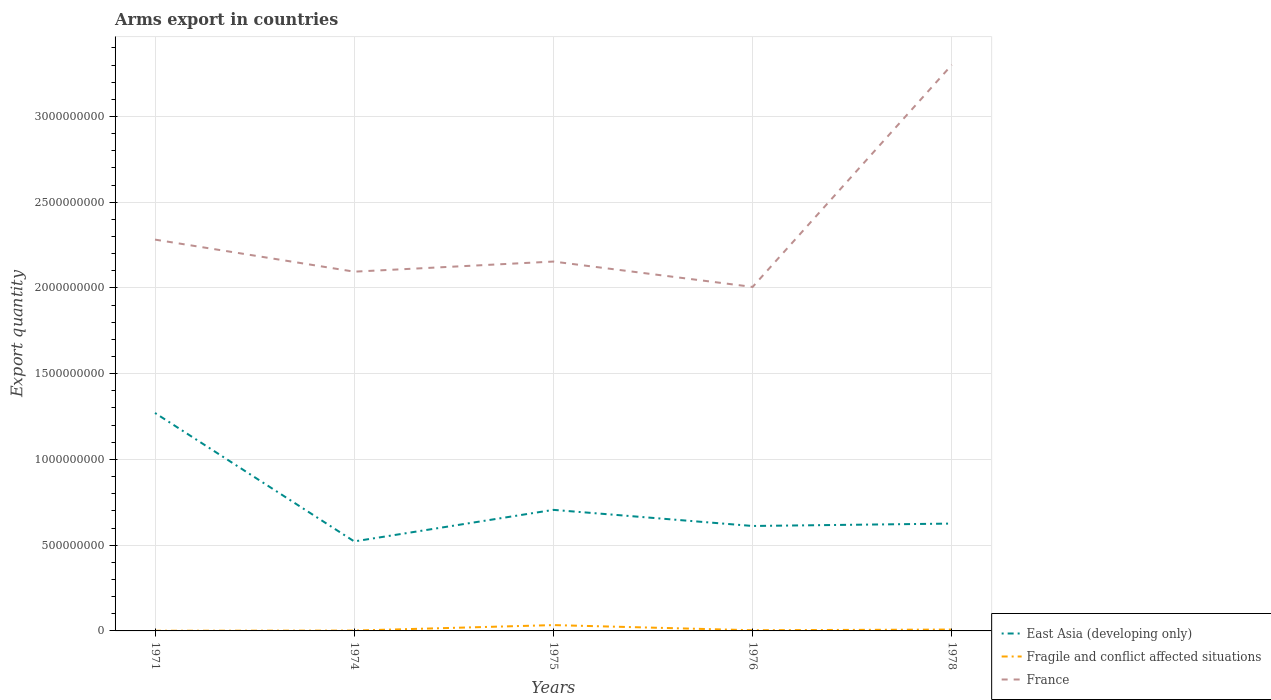How many different coloured lines are there?
Ensure brevity in your answer.  3. Across all years, what is the maximum total arms export in Fragile and conflict affected situations?
Keep it short and to the point. 1.00e+06. What is the total total arms export in East Asia (developing only) in the graph?
Provide a short and direct response. 5.65e+08. What is the difference between the highest and the second highest total arms export in Fragile and conflict affected situations?
Provide a succinct answer. 3.30e+07. Is the total arms export in Fragile and conflict affected situations strictly greater than the total arms export in France over the years?
Offer a terse response. Yes. Are the values on the major ticks of Y-axis written in scientific E-notation?
Make the answer very short. No. Does the graph contain any zero values?
Give a very brief answer. No. Does the graph contain grids?
Your answer should be very brief. Yes. Where does the legend appear in the graph?
Your answer should be compact. Bottom right. What is the title of the graph?
Your response must be concise. Arms export in countries. What is the label or title of the X-axis?
Provide a short and direct response. Years. What is the label or title of the Y-axis?
Make the answer very short. Export quantity. What is the Export quantity in East Asia (developing only) in 1971?
Your answer should be compact. 1.27e+09. What is the Export quantity of France in 1971?
Offer a very short reply. 2.28e+09. What is the Export quantity of East Asia (developing only) in 1974?
Keep it short and to the point. 5.22e+08. What is the Export quantity in France in 1974?
Provide a succinct answer. 2.10e+09. What is the Export quantity in East Asia (developing only) in 1975?
Make the answer very short. 7.06e+08. What is the Export quantity in Fragile and conflict affected situations in 1975?
Your answer should be compact. 3.40e+07. What is the Export quantity of France in 1975?
Your answer should be very brief. 2.15e+09. What is the Export quantity in East Asia (developing only) in 1976?
Provide a short and direct response. 6.12e+08. What is the Export quantity in France in 1976?
Provide a short and direct response. 2.01e+09. What is the Export quantity of East Asia (developing only) in 1978?
Make the answer very short. 6.26e+08. What is the Export quantity in France in 1978?
Keep it short and to the point. 3.30e+09. Across all years, what is the maximum Export quantity of East Asia (developing only)?
Provide a short and direct response. 1.27e+09. Across all years, what is the maximum Export quantity of Fragile and conflict affected situations?
Keep it short and to the point. 3.40e+07. Across all years, what is the maximum Export quantity of France?
Offer a terse response. 3.30e+09. Across all years, what is the minimum Export quantity of East Asia (developing only)?
Give a very brief answer. 5.22e+08. Across all years, what is the minimum Export quantity of Fragile and conflict affected situations?
Ensure brevity in your answer.  1.00e+06. Across all years, what is the minimum Export quantity of France?
Your answer should be compact. 2.01e+09. What is the total Export quantity in East Asia (developing only) in the graph?
Keep it short and to the point. 3.74e+09. What is the total Export quantity in Fragile and conflict affected situations in the graph?
Give a very brief answer. 4.90e+07. What is the total Export quantity of France in the graph?
Provide a succinct answer. 1.18e+1. What is the difference between the Export quantity of East Asia (developing only) in 1971 and that in 1974?
Offer a very short reply. 7.49e+08. What is the difference between the Export quantity in Fragile and conflict affected situations in 1971 and that in 1974?
Offer a very short reply. -1.00e+06. What is the difference between the Export quantity of France in 1971 and that in 1974?
Keep it short and to the point. 1.87e+08. What is the difference between the Export quantity of East Asia (developing only) in 1971 and that in 1975?
Ensure brevity in your answer.  5.65e+08. What is the difference between the Export quantity of Fragile and conflict affected situations in 1971 and that in 1975?
Offer a terse response. -3.30e+07. What is the difference between the Export quantity of France in 1971 and that in 1975?
Your answer should be very brief. 1.28e+08. What is the difference between the Export quantity in East Asia (developing only) in 1971 and that in 1976?
Your response must be concise. 6.59e+08. What is the difference between the Export quantity in France in 1971 and that in 1976?
Your answer should be very brief. 2.76e+08. What is the difference between the Export quantity of East Asia (developing only) in 1971 and that in 1978?
Keep it short and to the point. 6.45e+08. What is the difference between the Export quantity of Fragile and conflict affected situations in 1971 and that in 1978?
Offer a very short reply. -7.00e+06. What is the difference between the Export quantity of France in 1971 and that in 1978?
Make the answer very short. -1.02e+09. What is the difference between the Export quantity of East Asia (developing only) in 1974 and that in 1975?
Ensure brevity in your answer.  -1.84e+08. What is the difference between the Export quantity in Fragile and conflict affected situations in 1974 and that in 1975?
Provide a succinct answer. -3.20e+07. What is the difference between the Export quantity in France in 1974 and that in 1975?
Make the answer very short. -5.90e+07. What is the difference between the Export quantity of East Asia (developing only) in 1974 and that in 1976?
Provide a succinct answer. -9.00e+07. What is the difference between the Export quantity in Fragile and conflict affected situations in 1974 and that in 1976?
Your answer should be very brief. -2.00e+06. What is the difference between the Export quantity in France in 1974 and that in 1976?
Make the answer very short. 8.90e+07. What is the difference between the Export quantity of East Asia (developing only) in 1974 and that in 1978?
Provide a succinct answer. -1.04e+08. What is the difference between the Export quantity in Fragile and conflict affected situations in 1974 and that in 1978?
Offer a terse response. -6.00e+06. What is the difference between the Export quantity in France in 1974 and that in 1978?
Provide a succinct answer. -1.21e+09. What is the difference between the Export quantity of East Asia (developing only) in 1975 and that in 1976?
Keep it short and to the point. 9.40e+07. What is the difference between the Export quantity of Fragile and conflict affected situations in 1975 and that in 1976?
Your answer should be very brief. 3.00e+07. What is the difference between the Export quantity in France in 1975 and that in 1976?
Ensure brevity in your answer.  1.48e+08. What is the difference between the Export quantity of East Asia (developing only) in 1975 and that in 1978?
Offer a terse response. 8.00e+07. What is the difference between the Export quantity in Fragile and conflict affected situations in 1975 and that in 1978?
Keep it short and to the point. 2.60e+07. What is the difference between the Export quantity of France in 1975 and that in 1978?
Your answer should be very brief. -1.15e+09. What is the difference between the Export quantity in East Asia (developing only) in 1976 and that in 1978?
Your answer should be very brief. -1.40e+07. What is the difference between the Export quantity in France in 1976 and that in 1978?
Your answer should be very brief. -1.30e+09. What is the difference between the Export quantity of East Asia (developing only) in 1971 and the Export quantity of Fragile and conflict affected situations in 1974?
Your response must be concise. 1.27e+09. What is the difference between the Export quantity in East Asia (developing only) in 1971 and the Export quantity in France in 1974?
Your answer should be very brief. -8.24e+08. What is the difference between the Export quantity in Fragile and conflict affected situations in 1971 and the Export quantity in France in 1974?
Ensure brevity in your answer.  -2.09e+09. What is the difference between the Export quantity of East Asia (developing only) in 1971 and the Export quantity of Fragile and conflict affected situations in 1975?
Your answer should be very brief. 1.24e+09. What is the difference between the Export quantity of East Asia (developing only) in 1971 and the Export quantity of France in 1975?
Your answer should be very brief. -8.83e+08. What is the difference between the Export quantity in Fragile and conflict affected situations in 1971 and the Export quantity in France in 1975?
Offer a very short reply. -2.15e+09. What is the difference between the Export quantity in East Asia (developing only) in 1971 and the Export quantity in Fragile and conflict affected situations in 1976?
Ensure brevity in your answer.  1.27e+09. What is the difference between the Export quantity of East Asia (developing only) in 1971 and the Export quantity of France in 1976?
Ensure brevity in your answer.  -7.35e+08. What is the difference between the Export quantity of Fragile and conflict affected situations in 1971 and the Export quantity of France in 1976?
Your answer should be compact. -2.00e+09. What is the difference between the Export quantity in East Asia (developing only) in 1971 and the Export quantity in Fragile and conflict affected situations in 1978?
Your answer should be compact. 1.26e+09. What is the difference between the Export quantity in East Asia (developing only) in 1971 and the Export quantity in France in 1978?
Provide a short and direct response. -2.03e+09. What is the difference between the Export quantity in Fragile and conflict affected situations in 1971 and the Export quantity in France in 1978?
Provide a succinct answer. -3.30e+09. What is the difference between the Export quantity in East Asia (developing only) in 1974 and the Export quantity in Fragile and conflict affected situations in 1975?
Make the answer very short. 4.88e+08. What is the difference between the Export quantity in East Asia (developing only) in 1974 and the Export quantity in France in 1975?
Ensure brevity in your answer.  -1.63e+09. What is the difference between the Export quantity in Fragile and conflict affected situations in 1974 and the Export quantity in France in 1975?
Provide a short and direct response. -2.15e+09. What is the difference between the Export quantity in East Asia (developing only) in 1974 and the Export quantity in Fragile and conflict affected situations in 1976?
Your answer should be very brief. 5.18e+08. What is the difference between the Export quantity of East Asia (developing only) in 1974 and the Export quantity of France in 1976?
Provide a short and direct response. -1.48e+09. What is the difference between the Export quantity in Fragile and conflict affected situations in 1974 and the Export quantity in France in 1976?
Your response must be concise. -2.00e+09. What is the difference between the Export quantity in East Asia (developing only) in 1974 and the Export quantity in Fragile and conflict affected situations in 1978?
Provide a succinct answer. 5.14e+08. What is the difference between the Export quantity of East Asia (developing only) in 1974 and the Export quantity of France in 1978?
Ensure brevity in your answer.  -2.78e+09. What is the difference between the Export quantity of Fragile and conflict affected situations in 1974 and the Export quantity of France in 1978?
Your response must be concise. -3.30e+09. What is the difference between the Export quantity in East Asia (developing only) in 1975 and the Export quantity in Fragile and conflict affected situations in 1976?
Provide a succinct answer. 7.02e+08. What is the difference between the Export quantity in East Asia (developing only) in 1975 and the Export quantity in France in 1976?
Your response must be concise. -1.30e+09. What is the difference between the Export quantity in Fragile and conflict affected situations in 1975 and the Export quantity in France in 1976?
Offer a terse response. -1.97e+09. What is the difference between the Export quantity of East Asia (developing only) in 1975 and the Export quantity of Fragile and conflict affected situations in 1978?
Give a very brief answer. 6.98e+08. What is the difference between the Export quantity of East Asia (developing only) in 1975 and the Export quantity of France in 1978?
Provide a short and direct response. -2.60e+09. What is the difference between the Export quantity of Fragile and conflict affected situations in 1975 and the Export quantity of France in 1978?
Offer a very short reply. -3.27e+09. What is the difference between the Export quantity of East Asia (developing only) in 1976 and the Export quantity of Fragile and conflict affected situations in 1978?
Make the answer very short. 6.04e+08. What is the difference between the Export quantity of East Asia (developing only) in 1976 and the Export quantity of France in 1978?
Your answer should be very brief. -2.69e+09. What is the difference between the Export quantity in Fragile and conflict affected situations in 1976 and the Export quantity in France in 1978?
Offer a terse response. -3.30e+09. What is the average Export quantity in East Asia (developing only) per year?
Provide a short and direct response. 7.47e+08. What is the average Export quantity in Fragile and conflict affected situations per year?
Provide a short and direct response. 9.80e+06. What is the average Export quantity in France per year?
Your response must be concise. 2.37e+09. In the year 1971, what is the difference between the Export quantity in East Asia (developing only) and Export quantity in Fragile and conflict affected situations?
Offer a very short reply. 1.27e+09. In the year 1971, what is the difference between the Export quantity of East Asia (developing only) and Export quantity of France?
Offer a very short reply. -1.01e+09. In the year 1971, what is the difference between the Export quantity of Fragile and conflict affected situations and Export quantity of France?
Provide a succinct answer. -2.28e+09. In the year 1974, what is the difference between the Export quantity in East Asia (developing only) and Export quantity in Fragile and conflict affected situations?
Give a very brief answer. 5.20e+08. In the year 1974, what is the difference between the Export quantity of East Asia (developing only) and Export quantity of France?
Offer a very short reply. -1.57e+09. In the year 1974, what is the difference between the Export quantity in Fragile and conflict affected situations and Export quantity in France?
Your answer should be very brief. -2.09e+09. In the year 1975, what is the difference between the Export quantity of East Asia (developing only) and Export quantity of Fragile and conflict affected situations?
Keep it short and to the point. 6.72e+08. In the year 1975, what is the difference between the Export quantity of East Asia (developing only) and Export quantity of France?
Provide a succinct answer. -1.45e+09. In the year 1975, what is the difference between the Export quantity in Fragile and conflict affected situations and Export quantity in France?
Your answer should be compact. -2.12e+09. In the year 1976, what is the difference between the Export quantity of East Asia (developing only) and Export quantity of Fragile and conflict affected situations?
Keep it short and to the point. 6.08e+08. In the year 1976, what is the difference between the Export quantity of East Asia (developing only) and Export quantity of France?
Provide a short and direct response. -1.39e+09. In the year 1976, what is the difference between the Export quantity in Fragile and conflict affected situations and Export quantity in France?
Offer a terse response. -2.00e+09. In the year 1978, what is the difference between the Export quantity in East Asia (developing only) and Export quantity in Fragile and conflict affected situations?
Your answer should be very brief. 6.18e+08. In the year 1978, what is the difference between the Export quantity of East Asia (developing only) and Export quantity of France?
Your answer should be compact. -2.68e+09. In the year 1978, what is the difference between the Export quantity in Fragile and conflict affected situations and Export quantity in France?
Give a very brief answer. -3.29e+09. What is the ratio of the Export quantity of East Asia (developing only) in 1971 to that in 1974?
Keep it short and to the point. 2.43. What is the ratio of the Export quantity of France in 1971 to that in 1974?
Ensure brevity in your answer.  1.09. What is the ratio of the Export quantity in East Asia (developing only) in 1971 to that in 1975?
Provide a short and direct response. 1.8. What is the ratio of the Export quantity in Fragile and conflict affected situations in 1971 to that in 1975?
Make the answer very short. 0.03. What is the ratio of the Export quantity of France in 1971 to that in 1975?
Keep it short and to the point. 1.06. What is the ratio of the Export quantity in East Asia (developing only) in 1971 to that in 1976?
Provide a short and direct response. 2.08. What is the ratio of the Export quantity of Fragile and conflict affected situations in 1971 to that in 1976?
Provide a succinct answer. 0.25. What is the ratio of the Export quantity of France in 1971 to that in 1976?
Offer a very short reply. 1.14. What is the ratio of the Export quantity in East Asia (developing only) in 1971 to that in 1978?
Offer a very short reply. 2.03. What is the ratio of the Export quantity in Fragile and conflict affected situations in 1971 to that in 1978?
Offer a very short reply. 0.12. What is the ratio of the Export quantity of France in 1971 to that in 1978?
Ensure brevity in your answer.  0.69. What is the ratio of the Export quantity of East Asia (developing only) in 1974 to that in 1975?
Ensure brevity in your answer.  0.74. What is the ratio of the Export quantity of Fragile and conflict affected situations in 1974 to that in 1975?
Your answer should be compact. 0.06. What is the ratio of the Export quantity of France in 1974 to that in 1975?
Offer a very short reply. 0.97. What is the ratio of the Export quantity of East Asia (developing only) in 1974 to that in 1976?
Your answer should be very brief. 0.85. What is the ratio of the Export quantity in Fragile and conflict affected situations in 1974 to that in 1976?
Your answer should be very brief. 0.5. What is the ratio of the Export quantity of France in 1974 to that in 1976?
Make the answer very short. 1.04. What is the ratio of the Export quantity of East Asia (developing only) in 1974 to that in 1978?
Ensure brevity in your answer.  0.83. What is the ratio of the Export quantity in France in 1974 to that in 1978?
Ensure brevity in your answer.  0.63. What is the ratio of the Export quantity in East Asia (developing only) in 1975 to that in 1976?
Make the answer very short. 1.15. What is the ratio of the Export quantity of Fragile and conflict affected situations in 1975 to that in 1976?
Your answer should be compact. 8.5. What is the ratio of the Export quantity in France in 1975 to that in 1976?
Offer a very short reply. 1.07. What is the ratio of the Export quantity of East Asia (developing only) in 1975 to that in 1978?
Give a very brief answer. 1.13. What is the ratio of the Export quantity in Fragile and conflict affected situations in 1975 to that in 1978?
Your answer should be compact. 4.25. What is the ratio of the Export quantity in France in 1975 to that in 1978?
Make the answer very short. 0.65. What is the ratio of the Export quantity in East Asia (developing only) in 1976 to that in 1978?
Your response must be concise. 0.98. What is the ratio of the Export quantity of France in 1976 to that in 1978?
Your answer should be compact. 0.61. What is the difference between the highest and the second highest Export quantity of East Asia (developing only)?
Ensure brevity in your answer.  5.65e+08. What is the difference between the highest and the second highest Export quantity in Fragile and conflict affected situations?
Keep it short and to the point. 2.60e+07. What is the difference between the highest and the second highest Export quantity of France?
Offer a terse response. 1.02e+09. What is the difference between the highest and the lowest Export quantity in East Asia (developing only)?
Your answer should be very brief. 7.49e+08. What is the difference between the highest and the lowest Export quantity of Fragile and conflict affected situations?
Offer a very short reply. 3.30e+07. What is the difference between the highest and the lowest Export quantity of France?
Offer a very short reply. 1.30e+09. 